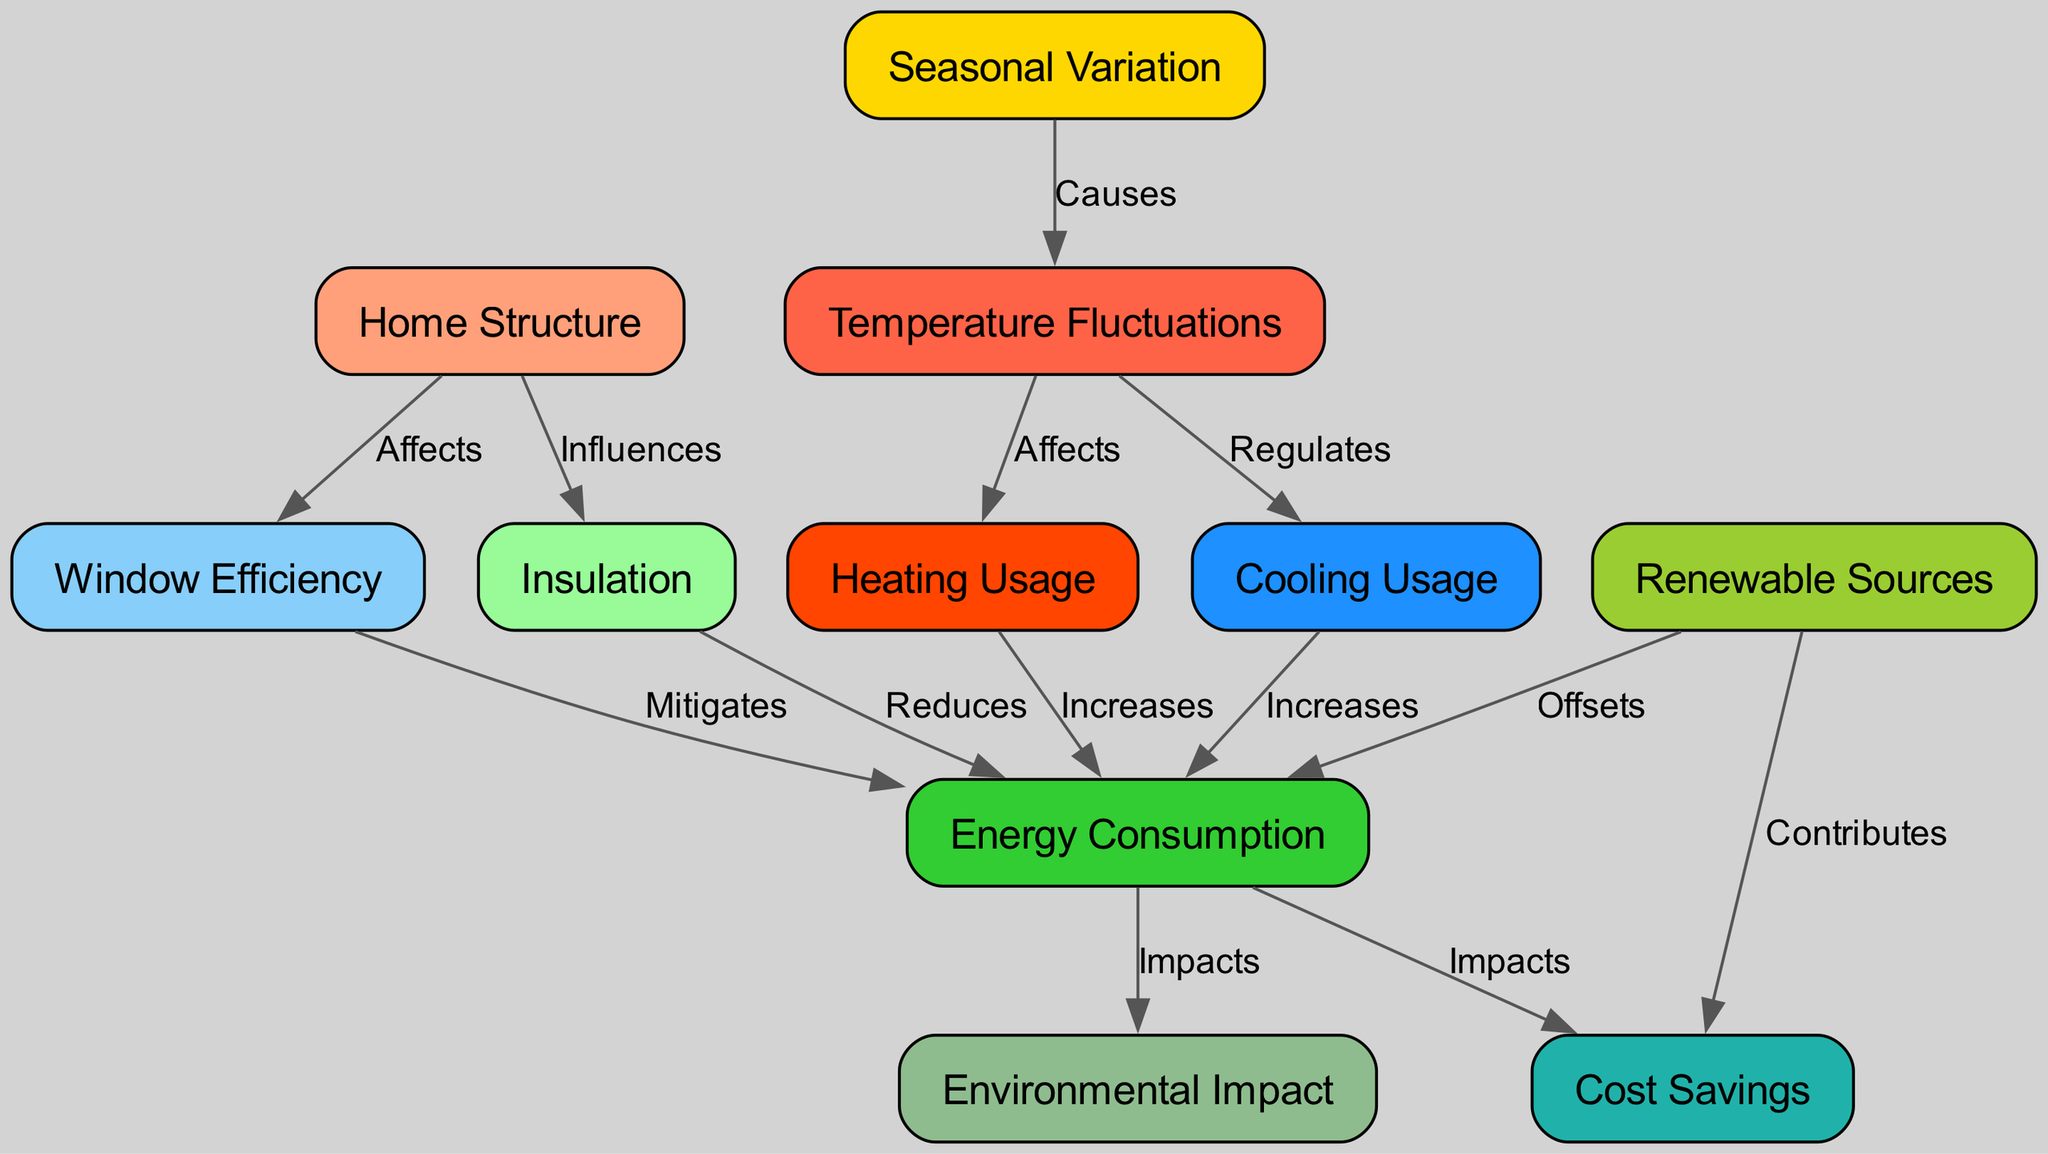What node influences insulation? The diagram shows that the "Home Structure" node has an edge labeled "Influences" pointing to the "Insulation" node. This indicates a direct influence relationship where the characteristics of the home structure can impact insulation quality.
Answer: Home Structure How many nodes are in the diagram? By counting the nodes listed in the data provided, there are a total of 11 distinct nodes in the diagram representing various aspects affecting energy consumption.
Answer: 11 What is the impact of energy consumption on cost savings? The diagram indicates a direct relationship where "Energy Consumption" impacts "Cost Savings" through an edge labeled "Impacts". This means higher or lower energy consumption can directly influence the amount of cost savings experienced.
Answer: Impacts Which node reduces energy consumption? According to the diagram, the "Insulation" node has an edge labeled "Reduces" pointing to "Energy Consumption", indicating that improved insulation can lead to decreased energy consumption levels.
Answer: Insulation What causes temperature fluctuations? The edge labeled "Causes" from "Seasonal Variation" to "Temperature Fluctuations" in the diagram indicates that changes in seasons lead to variations in temperature fluctuations within a home environment.
Answer: Seasonal Variation What two nodes increase energy consumption? The diagram shows that both "Heating Usage" and "Cooling Usage" have edges labeled "Increases" pointing to "Energy Consumption". This indicates that higher usage of either heating or cooling systems directly leads to increased energy consumption.
Answer: Heating Usage, Cooling Usage How does insulation affect energy consumption? The diagram shows an edge labeled "Reduces" from "Insulation" to "Energy Consumption", indicating that better insulation results in lower overall energy consumption for a home.
Answer: Reduces What contributes to cost savings? The diagram illustrates that both "Renewable Sources," which contributes towards "Cost Savings," and "Energy Consumption," which also impacts "Cost Savings," show that using renewable energy sources alongside managing energy consumption can lead to financial benefits.
Answer: Renewable Sources Which node is affected by window efficiency? The arrow from "Window Efficiency" to "Energy Consumption" labeled "Mitigates" in the diagram indicates that window efficiency has a direct effect on energy consumption levels, specifically helping to mitigate it.
Answer: Energy Consumption 